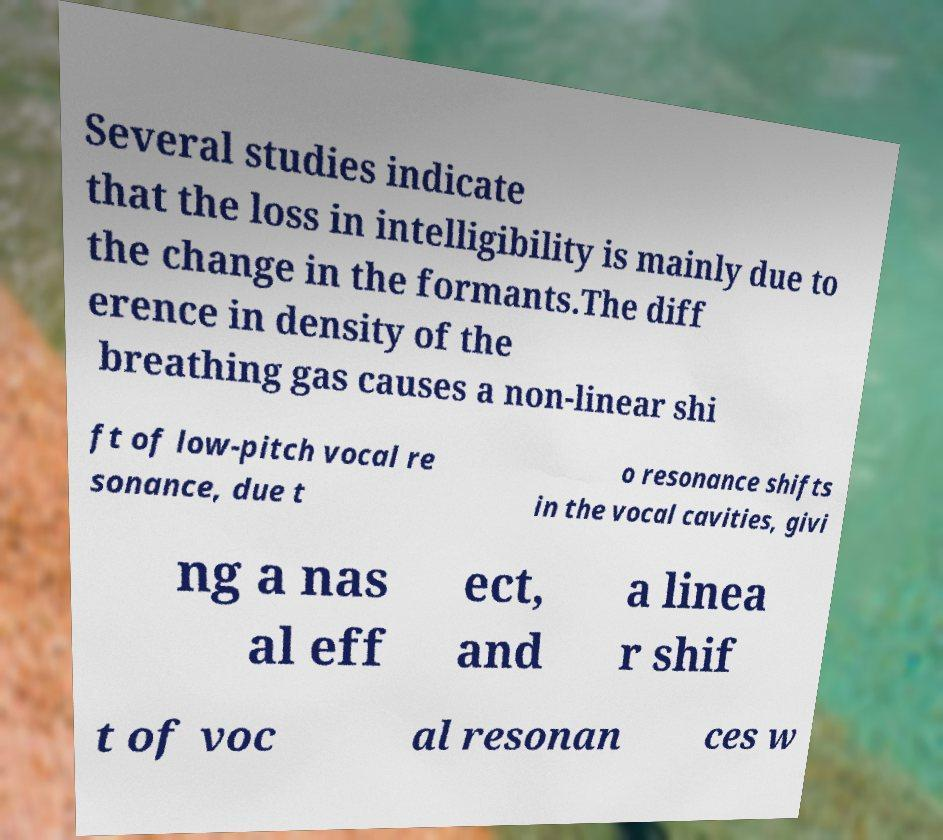I need the written content from this picture converted into text. Can you do that? Several studies indicate that the loss in intelligibility is mainly due to the change in the formants.The diff erence in density of the breathing gas causes a non-linear shi ft of low-pitch vocal re sonance, due t o resonance shifts in the vocal cavities, givi ng a nas al eff ect, and a linea r shif t of voc al resonan ces w 